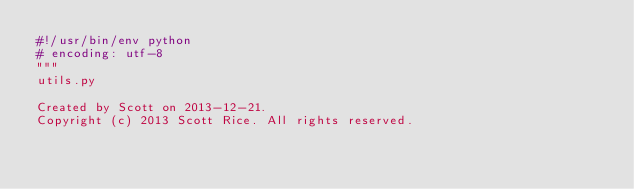<code> <loc_0><loc_0><loc_500><loc_500><_Python_>#!/usr/bin/env python
# encoding: utf-8
"""
utils.py

Created by Scott on 2013-12-21.
Copyright (c) 2013 Scott Rice. All rights reserved.
</code> 